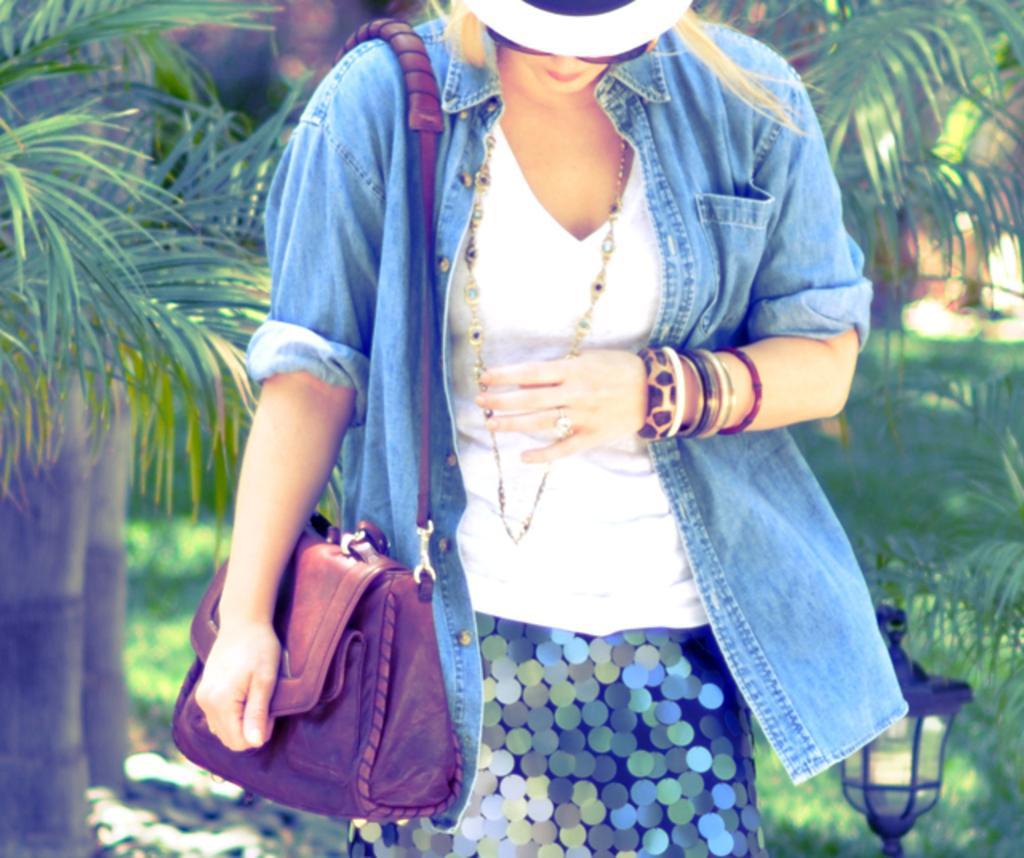Could you give a brief overview of what you see in this image? This is a outdoor picture. This picture is highlighted with a woman, standing and looking toward the ground. She is wearing a denim blue jacket and a white shirt and there is a chain on her neck. We can see bangles. Here she is wearing a brown leather handbag. She wore a cap and she is also wearing specs and her hair light brown in colour. On the background of the picture we can see trees. On the right side there is light. 